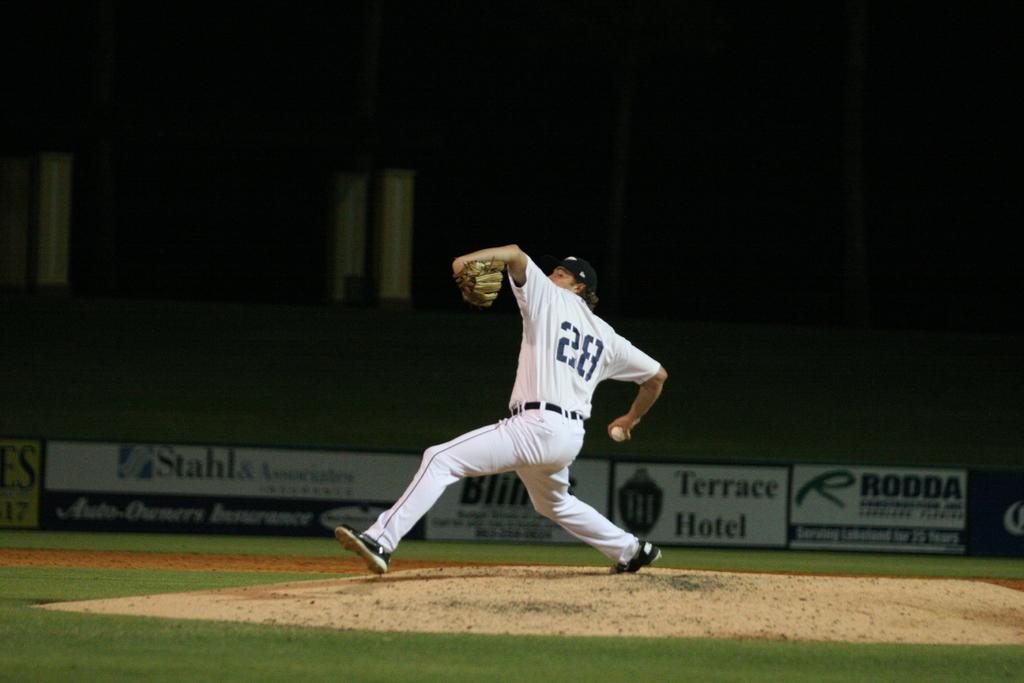What is the number on the pitchers back ?
Your answer should be compact. 28. What hotel is being advertised on the banner behind the player?
Your response must be concise. Terrace. 